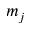Convert formula to latex. <formula><loc_0><loc_0><loc_500><loc_500>m _ { j }</formula> 